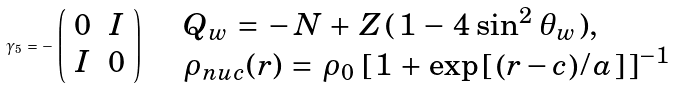<formula> <loc_0><loc_0><loc_500><loc_500>\gamma _ { 5 } \, = \, - \, \left ( \begin{array} { c c } 0 & I \\ I & 0 \end{array} \right ) \quad \begin{array} { l } Q _ { w } \, = \, - \, N \, + \, Z \, ( \, 1 \, - \, 4 \, \sin ^ { 2 } \, \theta _ { w } \, ) , \\ \rho _ { n u c } ( r ) \, = \, \rho _ { 0 } \, \left [ \, 1 \, + \, \exp \left [ \, \left ( r - c \right ) / \, a \, \right ] \, \right ] ^ { - 1 } \end{array}</formula> 